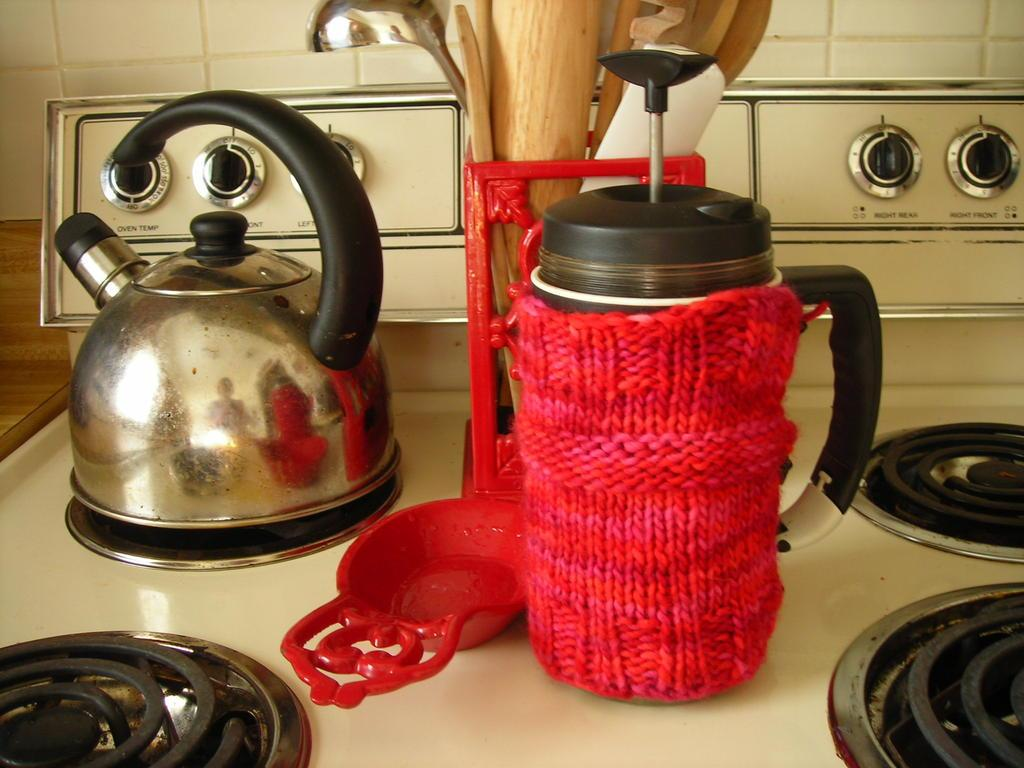<image>
Summarize the visual content of the image. A stove top with knobs reading "oven temp", "right front", "left front", "right rear", and "left rear". 